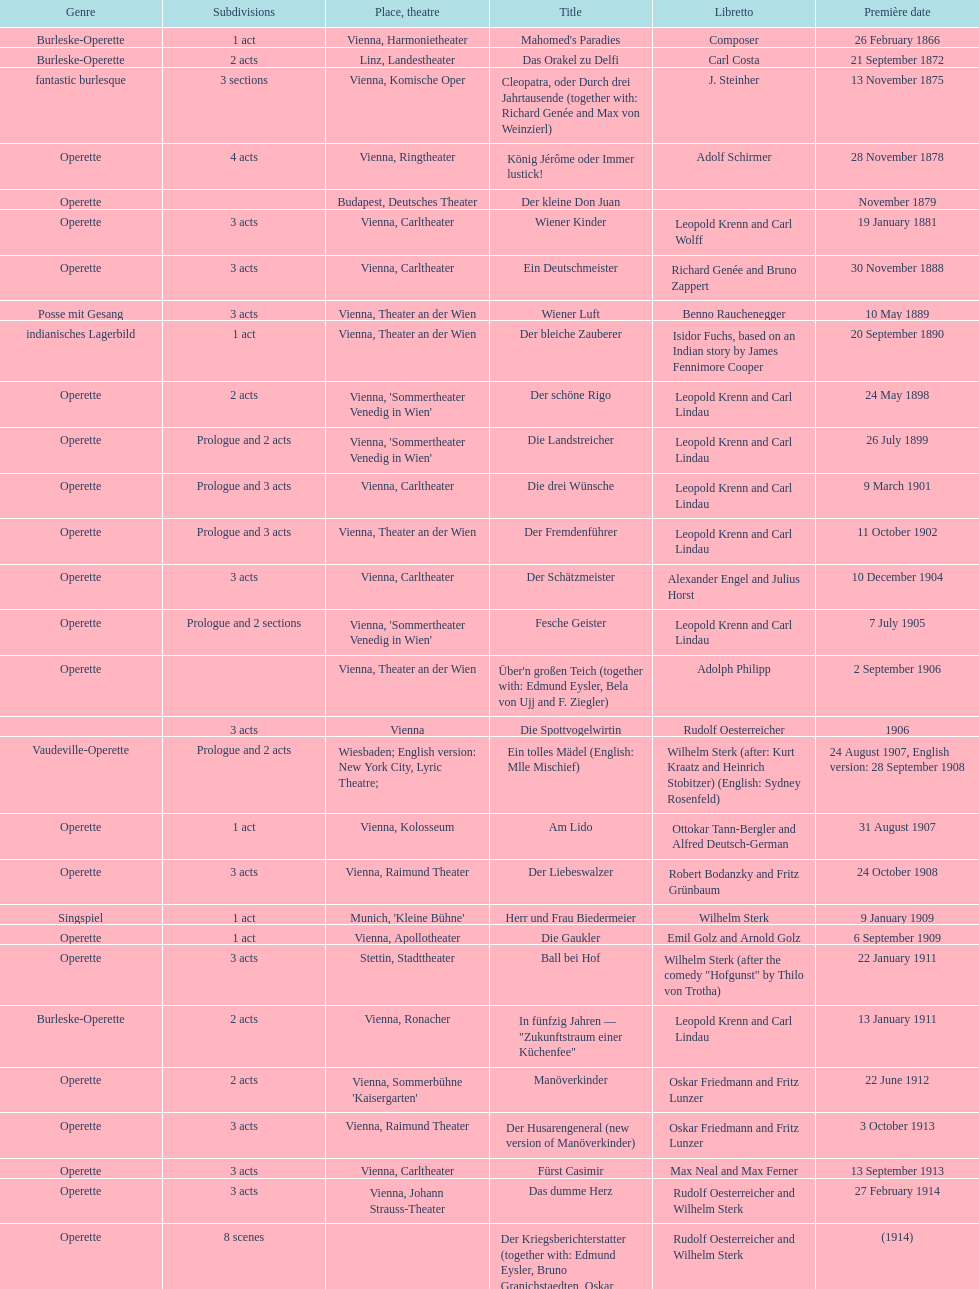Which style is emphasized the most in this graph? Operette. 